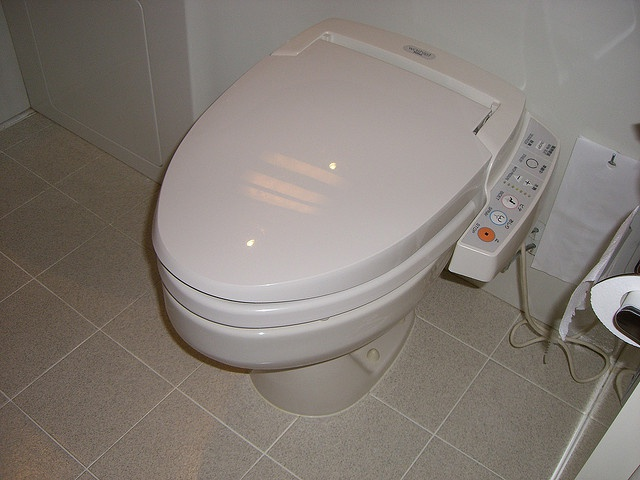Describe the objects in this image and their specific colors. I can see a toilet in black, darkgray, and gray tones in this image. 